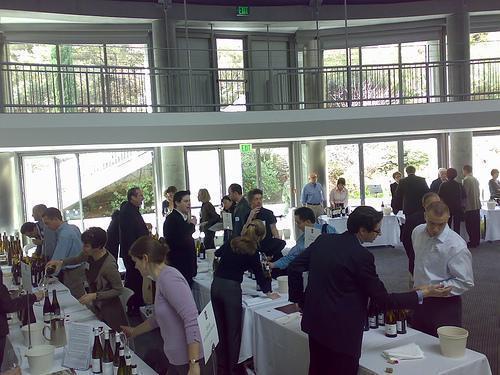What is on the table to the left?
Choose the right answer and clarify with the format: 'Answer: answer
Rationale: rationale.'
Options: Dog, chicken leg, wine bottles, cat. Answer: wine bottles.
Rationale: The wine bottles are on the left. 